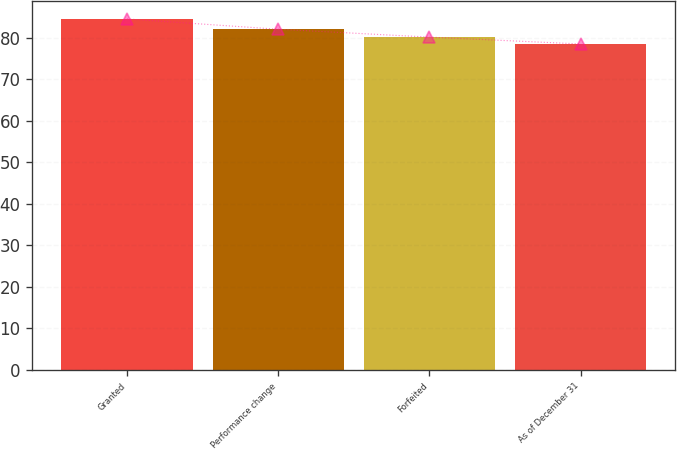Convert chart to OTSL. <chart><loc_0><loc_0><loc_500><loc_500><bar_chart><fcel>Granted<fcel>Performance change<fcel>Forfeited<fcel>As of December 31<nl><fcel>84.58<fcel>82.1<fcel>80.2<fcel>78.55<nl></chart> 